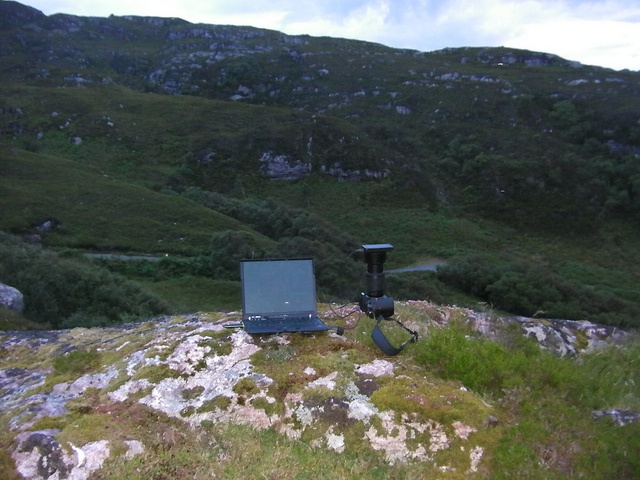Describe the objects in this image and their specific colors. I can see a laptop in blue, gray, darkblue, and navy tones in this image. 